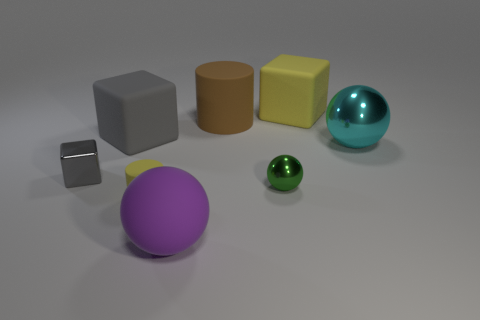Subtract all gray cubes. How many were subtracted if there are1gray cubes left? 1 Add 1 large gray things. How many objects exist? 9 Subtract all spheres. How many objects are left? 5 Add 4 metallic spheres. How many metallic spheres are left? 6 Add 7 tiny green metal spheres. How many tiny green metal spheres exist? 8 Subtract 0 purple cubes. How many objects are left? 8 Subtract all yellow matte objects. Subtract all yellow matte objects. How many objects are left? 4 